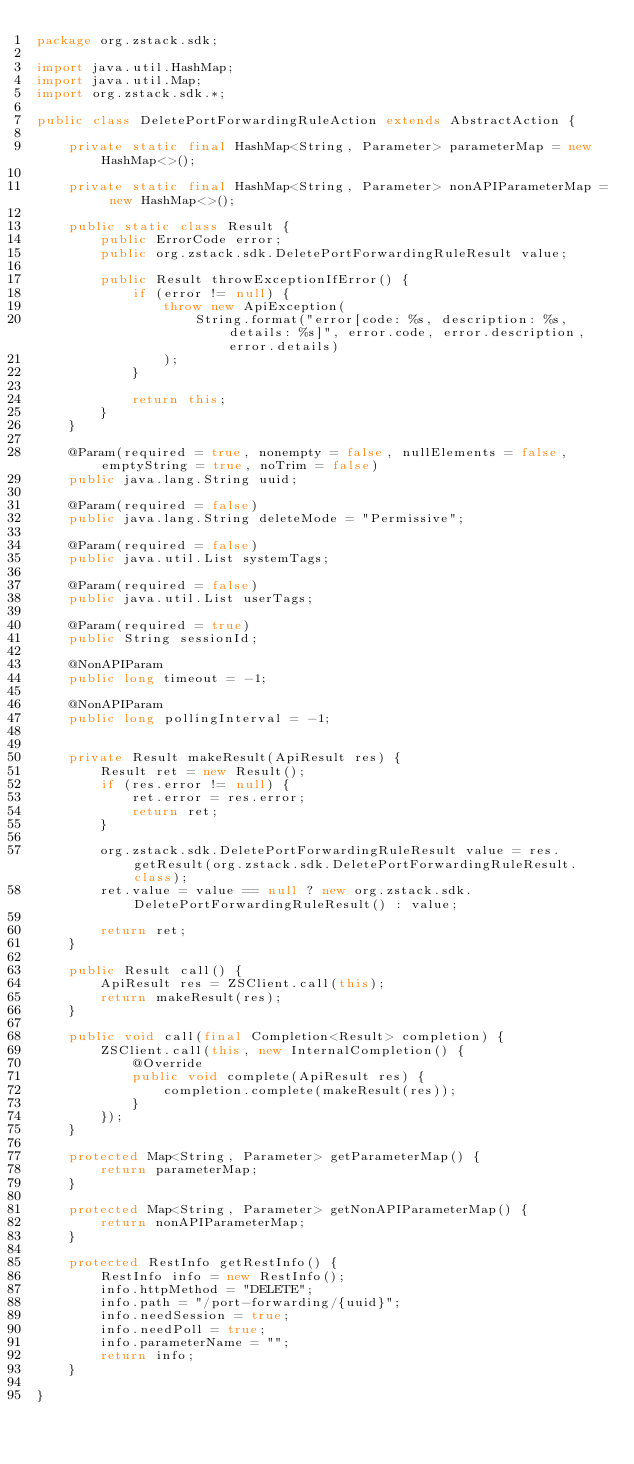<code> <loc_0><loc_0><loc_500><loc_500><_Java_>package org.zstack.sdk;

import java.util.HashMap;
import java.util.Map;
import org.zstack.sdk.*;

public class DeletePortForwardingRuleAction extends AbstractAction {

    private static final HashMap<String, Parameter> parameterMap = new HashMap<>();

    private static final HashMap<String, Parameter> nonAPIParameterMap = new HashMap<>();

    public static class Result {
        public ErrorCode error;
        public org.zstack.sdk.DeletePortForwardingRuleResult value;

        public Result throwExceptionIfError() {
            if (error != null) {
                throw new ApiException(
                    String.format("error[code: %s, description: %s, details: %s]", error.code, error.description, error.details)
                );
            }
            
            return this;
        }
    }

    @Param(required = true, nonempty = false, nullElements = false, emptyString = true, noTrim = false)
    public java.lang.String uuid;

    @Param(required = false)
    public java.lang.String deleteMode = "Permissive";

    @Param(required = false)
    public java.util.List systemTags;

    @Param(required = false)
    public java.util.List userTags;

    @Param(required = true)
    public String sessionId;

    @NonAPIParam
    public long timeout = -1;

    @NonAPIParam
    public long pollingInterval = -1;


    private Result makeResult(ApiResult res) {
        Result ret = new Result();
        if (res.error != null) {
            ret.error = res.error;
            return ret;
        }
        
        org.zstack.sdk.DeletePortForwardingRuleResult value = res.getResult(org.zstack.sdk.DeletePortForwardingRuleResult.class);
        ret.value = value == null ? new org.zstack.sdk.DeletePortForwardingRuleResult() : value; 

        return ret;
    }

    public Result call() {
        ApiResult res = ZSClient.call(this);
        return makeResult(res);
    }

    public void call(final Completion<Result> completion) {
        ZSClient.call(this, new InternalCompletion() {
            @Override
            public void complete(ApiResult res) {
                completion.complete(makeResult(res));
            }
        });
    }

    protected Map<String, Parameter> getParameterMap() {
        return parameterMap;
    }

    protected Map<String, Parameter> getNonAPIParameterMap() {
        return nonAPIParameterMap;
    }

    protected RestInfo getRestInfo() {
        RestInfo info = new RestInfo();
        info.httpMethod = "DELETE";
        info.path = "/port-forwarding/{uuid}";
        info.needSession = true;
        info.needPoll = true;
        info.parameterName = "";
        return info;
    }

}
</code> 